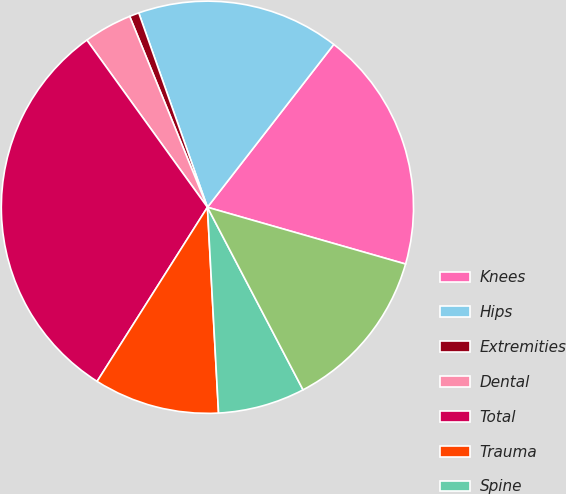<chart> <loc_0><loc_0><loc_500><loc_500><pie_chart><fcel>Knees<fcel>Hips<fcel>Extremities<fcel>Dental<fcel>Total<fcel>Trauma<fcel>Spine<fcel>OSP and other<nl><fcel>18.94%<fcel>15.91%<fcel>0.75%<fcel>3.79%<fcel>31.07%<fcel>9.85%<fcel>6.82%<fcel>12.88%<nl></chart> 